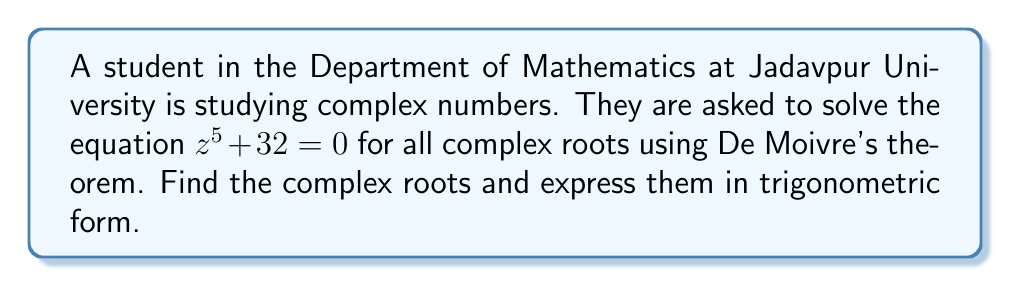What is the answer to this math problem? Let's solve this step-by-step using De Moivre's theorem:

1) First, rearrange the equation to standard form:
   $z^5 = -32$

2) Express -32 in polar form:
   $-32 = 32(\cos \pi + i \sin \pi)$

3) Now, we can write the equation as:
   $z^5 = 32(\cos \pi + i \sin \pi)$

4) Using De Moivre's theorem, we can write the general solution as:
   $z_k = \sqrt[5]{32} \left(\cos \frac{\pi + 2k\pi}{5} + i \sin \frac{\pi + 2k\pi}{5}\right)$
   where $k = 0, 1, 2, 3, 4$

5) Calculate $\sqrt[5]{32}$:
   $\sqrt[5]{32} = 2$

6) Now, we can write out all five roots:

   For $k = 0$: $z_0 = 2\left(\cos \frac{\pi}{5} + i \sin \frac{\pi}{5}\right)$

   For $k = 1$: $z_1 = 2\left(\cos \frac{3\pi}{5} + i \sin \frac{3\pi}{5}\right)$

   For $k = 2$: $z_2 = 2\left(\cos \frac{5\pi}{5} + i \sin \frac{5\pi}{5}\right) = -2$

   For $k = 3$: $z_3 = 2\left(\cos \frac{7\pi}{5} + i \sin \frac{7\pi}{5}\right)$

   For $k = 4$: $z_4 = 2\left(\cos \frac{9\pi}{5} + i \sin \frac{9\pi}{5}\right)$

These are all the complex roots of the equation $z^5 + 32 = 0$ in trigonometric form.
Answer: $z_k = 2\left(\cos \frac{\pi + 2k\pi}{5} + i \sin \frac{\pi + 2k\pi}{5}\right)$, where $k = 0, 1, 2, 3, 4$ 